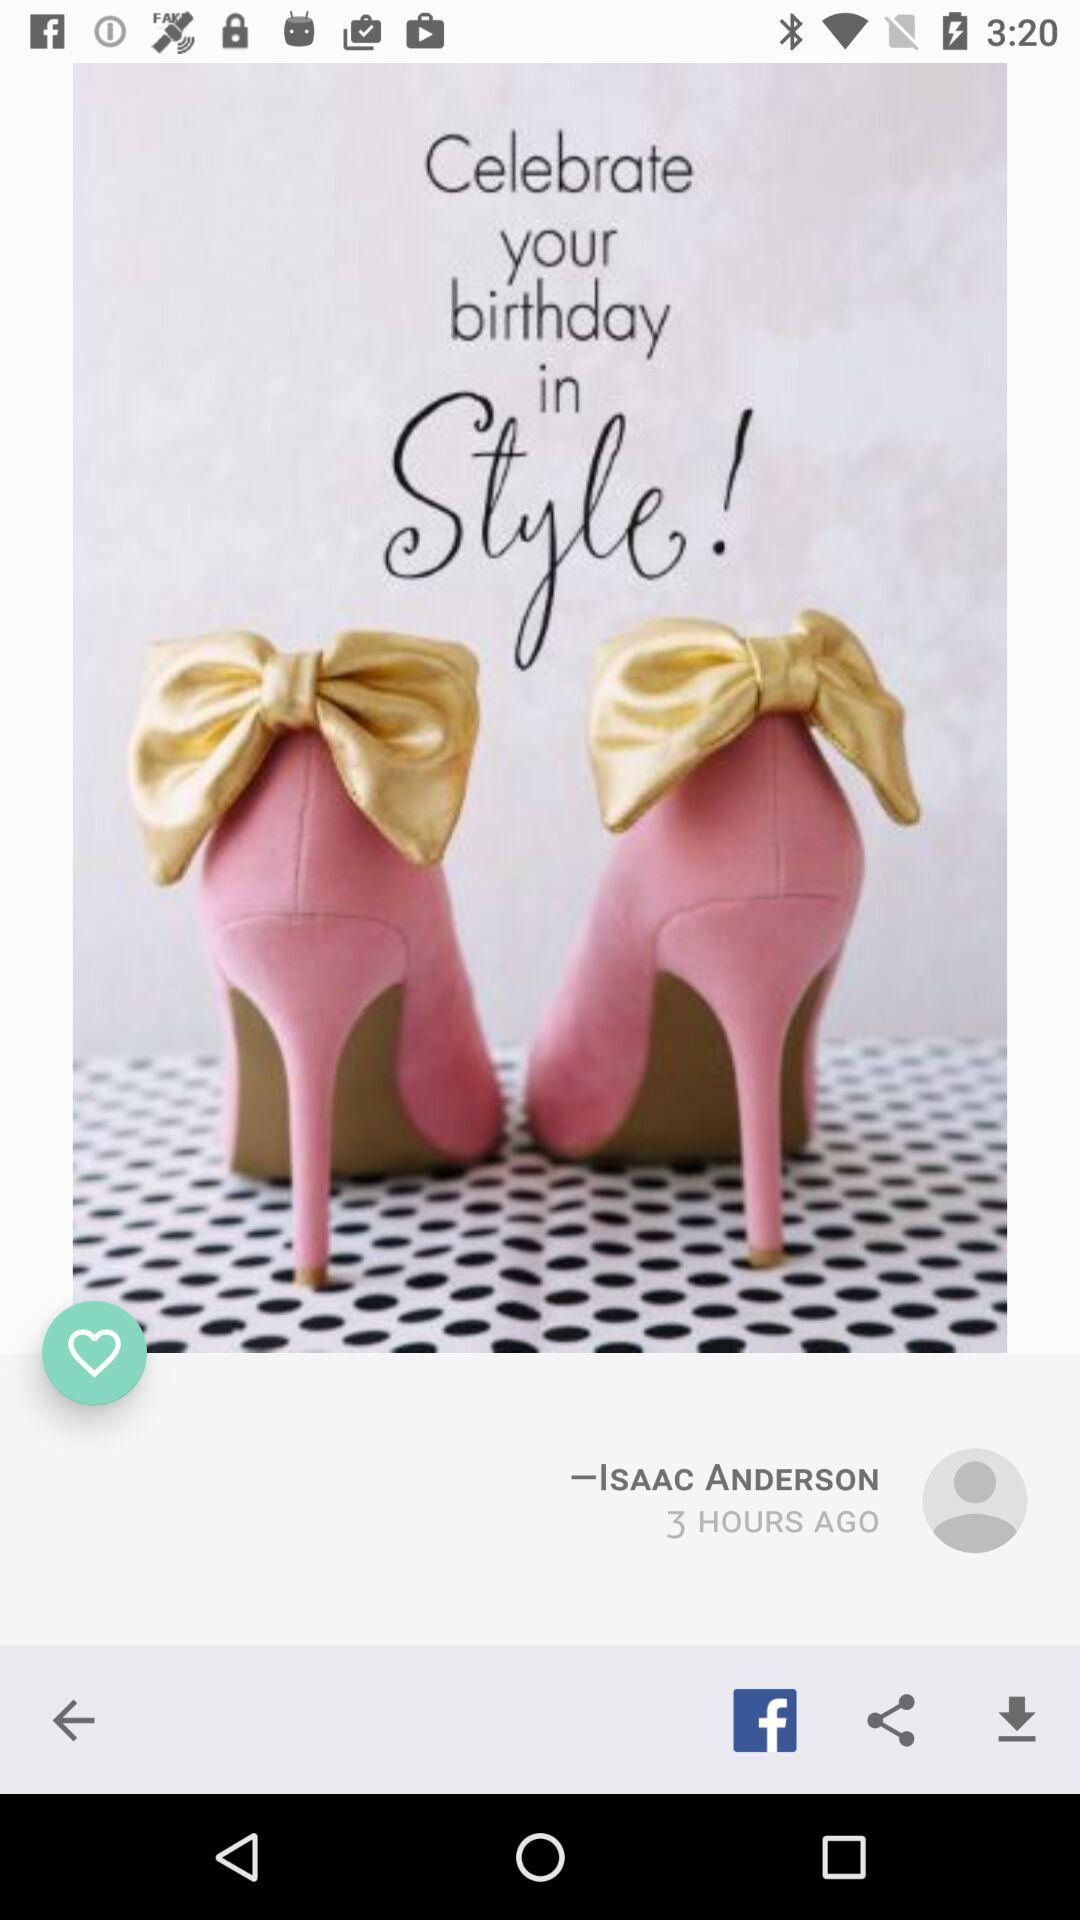What is the user name? The user name is Isaac Anderson. 